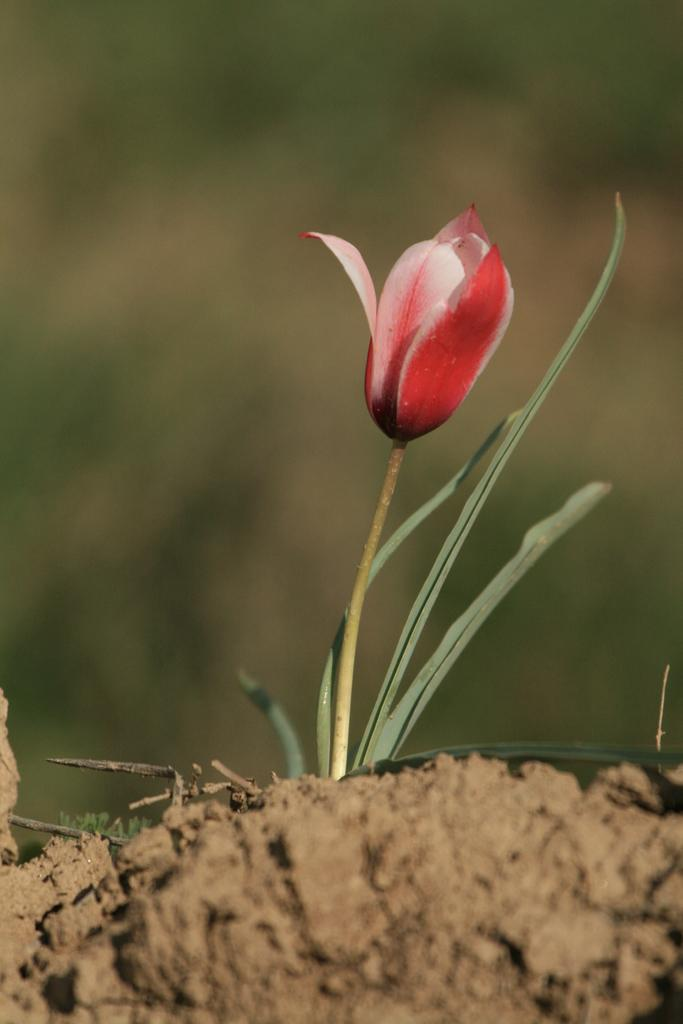What is present on the ground in the image? There is a flower on the ground in the image. What type of cart can be seen playing music in the background of the image? There is no cart or music present in the image; it only features a flower on the ground. 